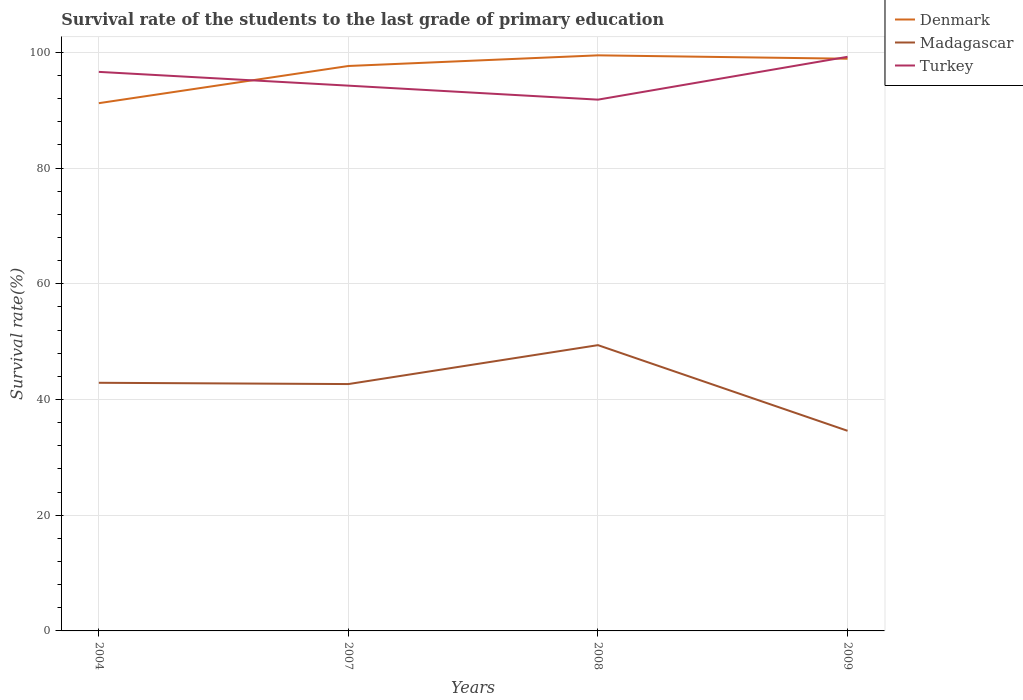How many different coloured lines are there?
Offer a terse response. 3. Does the line corresponding to Turkey intersect with the line corresponding to Madagascar?
Offer a terse response. No. Is the number of lines equal to the number of legend labels?
Provide a short and direct response. Yes. Across all years, what is the maximum survival rate of the students in Madagascar?
Make the answer very short. 34.58. What is the total survival rate of the students in Madagascar in the graph?
Offer a very short reply. 8.08. What is the difference between the highest and the second highest survival rate of the students in Denmark?
Offer a very short reply. 8.26. What is the difference between the highest and the lowest survival rate of the students in Denmark?
Make the answer very short. 3. What is the difference between two consecutive major ticks on the Y-axis?
Ensure brevity in your answer.  20. Does the graph contain any zero values?
Your answer should be compact. No. Does the graph contain grids?
Offer a very short reply. Yes. Where does the legend appear in the graph?
Offer a very short reply. Top right. How are the legend labels stacked?
Your response must be concise. Vertical. What is the title of the graph?
Provide a short and direct response. Survival rate of the students to the last grade of primary education. Does "Korea (Democratic)" appear as one of the legend labels in the graph?
Provide a short and direct response. No. What is the label or title of the X-axis?
Offer a terse response. Years. What is the label or title of the Y-axis?
Offer a terse response. Survival rate(%). What is the Survival rate(%) of Denmark in 2004?
Make the answer very short. 91.2. What is the Survival rate(%) in Madagascar in 2004?
Provide a short and direct response. 42.88. What is the Survival rate(%) in Turkey in 2004?
Ensure brevity in your answer.  96.61. What is the Survival rate(%) in Denmark in 2007?
Make the answer very short. 97.63. What is the Survival rate(%) in Madagascar in 2007?
Provide a short and direct response. 42.66. What is the Survival rate(%) of Turkey in 2007?
Give a very brief answer. 94.23. What is the Survival rate(%) of Denmark in 2008?
Provide a succinct answer. 99.47. What is the Survival rate(%) in Madagascar in 2008?
Your response must be concise. 49.39. What is the Survival rate(%) of Turkey in 2008?
Offer a very short reply. 91.81. What is the Survival rate(%) of Denmark in 2009?
Provide a succinct answer. 98.89. What is the Survival rate(%) in Madagascar in 2009?
Offer a very short reply. 34.58. What is the Survival rate(%) of Turkey in 2009?
Make the answer very short. 99.22. Across all years, what is the maximum Survival rate(%) of Denmark?
Your response must be concise. 99.47. Across all years, what is the maximum Survival rate(%) of Madagascar?
Make the answer very short. 49.39. Across all years, what is the maximum Survival rate(%) in Turkey?
Offer a very short reply. 99.22. Across all years, what is the minimum Survival rate(%) of Denmark?
Give a very brief answer. 91.2. Across all years, what is the minimum Survival rate(%) in Madagascar?
Your answer should be very brief. 34.58. Across all years, what is the minimum Survival rate(%) in Turkey?
Make the answer very short. 91.81. What is the total Survival rate(%) of Denmark in the graph?
Provide a short and direct response. 387.19. What is the total Survival rate(%) in Madagascar in the graph?
Your answer should be compact. 169.51. What is the total Survival rate(%) in Turkey in the graph?
Offer a terse response. 381.88. What is the difference between the Survival rate(%) in Denmark in 2004 and that in 2007?
Your answer should be compact. -6.43. What is the difference between the Survival rate(%) in Madagascar in 2004 and that in 2007?
Ensure brevity in your answer.  0.22. What is the difference between the Survival rate(%) of Turkey in 2004 and that in 2007?
Make the answer very short. 2.38. What is the difference between the Survival rate(%) in Denmark in 2004 and that in 2008?
Your answer should be very brief. -8.26. What is the difference between the Survival rate(%) of Madagascar in 2004 and that in 2008?
Your answer should be very brief. -6.5. What is the difference between the Survival rate(%) of Turkey in 2004 and that in 2008?
Your answer should be very brief. 4.8. What is the difference between the Survival rate(%) in Denmark in 2004 and that in 2009?
Your answer should be compact. -7.68. What is the difference between the Survival rate(%) in Madagascar in 2004 and that in 2009?
Your response must be concise. 8.3. What is the difference between the Survival rate(%) of Turkey in 2004 and that in 2009?
Give a very brief answer. -2.61. What is the difference between the Survival rate(%) in Denmark in 2007 and that in 2008?
Your response must be concise. -1.84. What is the difference between the Survival rate(%) in Madagascar in 2007 and that in 2008?
Keep it short and to the point. -6.73. What is the difference between the Survival rate(%) in Turkey in 2007 and that in 2008?
Offer a very short reply. 2.42. What is the difference between the Survival rate(%) of Denmark in 2007 and that in 2009?
Offer a very short reply. -1.26. What is the difference between the Survival rate(%) of Madagascar in 2007 and that in 2009?
Offer a terse response. 8.08. What is the difference between the Survival rate(%) in Turkey in 2007 and that in 2009?
Offer a very short reply. -4.99. What is the difference between the Survival rate(%) of Denmark in 2008 and that in 2009?
Your answer should be compact. 0.58. What is the difference between the Survival rate(%) of Madagascar in 2008 and that in 2009?
Provide a succinct answer. 14.8. What is the difference between the Survival rate(%) of Turkey in 2008 and that in 2009?
Give a very brief answer. -7.41. What is the difference between the Survival rate(%) in Denmark in 2004 and the Survival rate(%) in Madagascar in 2007?
Give a very brief answer. 48.54. What is the difference between the Survival rate(%) in Denmark in 2004 and the Survival rate(%) in Turkey in 2007?
Offer a very short reply. -3.03. What is the difference between the Survival rate(%) in Madagascar in 2004 and the Survival rate(%) in Turkey in 2007?
Ensure brevity in your answer.  -51.35. What is the difference between the Survival rate(%) of Denmark in 2004 and the Survival rate(%) of Madagascar in 2008?
Your response must be concise. 41.82. What is the difference between the Survival rate(%) in Denmark in 2004 and the Survival rate(%) in Turkey in 2008?
Provide a short and direct response. -0.61. What is the difference between the Survival rate(%) in Madagascar in 2004 and the Survival rate(%) in Turkey in 2008?
Your answer should be compact. -48.93. What is the difference between the Survival rate(%) in Denmark in 2004 and the Survival rate(%) in Madagascar in 2009?
Provide a short and direct response. 56.62. What is the difference between the Survival rate(%) in Denmark in 2004 and the Survival rate(%) in Turkey in 2009?
Your answer should be very brief. -8.01. What is the difference between the Survival rate(%) in Madagascar in 2004 and the Survival rate(%) in Turkey in 2009?
Provide a succinct answer. -56.34. What is the difference between the Survival rate(%) of Denmark in 2007 and the Survival rate(%) of Madagascar in 2008?
Your answer should be compact. 48.24. What is the difference between the Survival rate(%) of Denmark in 2007 and the Survival rate(%) of Turkey in 2008?
Your answer should be very brief. 5.82. What is the difference between the Survival rate(%) in Madagascar in 2007 and the Survival rate(%) in Turkey in 2008?
Make the answer very short. -49.15. What is the difference between the Survival rate(%) of Denmark in 2007 and the Survival rate(%) of Madagascar in 2009?
Offer a very short reply. 63.05. What is the difference between the Survival rate(%) of Denmark in 2007 and the Survival rate(%) of Turkey in 2009?
Your answer should be very brief. -1.59. What is the difference between the Survival rate(%) of Madagascar in 2007 and the Survival rate(%) of Turkey in 2009?
Your response must be concise. -56.56. What is the difference between the Survival rate(%) in Denmark in 2008 and the Survival rate(%) in Madagascar in 2009?
Provide a short and direct response. 64.88. What is the difference between the Survival rate(%) of Denmark in 2008 and the Survival rate(%) of Turkey in 2009?
Provide a succinct answer. 0.25. What is the difference between the Survival rate(%) of Madagascar in 2008 and the Survival rate(%) of Turkey in 2009?
Offer a terse response. -49.83. What is the average Survival rate(%) in Denmark per year?
Provide a short and direct response. 96.8. What is the average Survival rate(%) in Madagascar per year?
Ensure brevity in your answer.  42.38. What is the average Survival rate(%) of Turkey per year?
Keep it short and to the point. 95.47. In the year 2004, what is the difference between the Survival rate(%) of Denmark and Survival rate(%) of Madagascar?
Offer a very short reply. 48.32. In the year 2004, what is the difference between the Survival rate(%) of Denmark and Survival rate(%) of Turkey?
Your response must be concise. -5.41. In the year 2004, what is the difference between the Survival rate(%) of Madagascar and Survival rate(%) of Turkey?
Your response must be concise. -53.73. In the year 2007, what is the difference between the Survival rate(%) of Denmark and Survival rate(%) of Madagascar?
Make the answer very short. 54.97. In the year 2007, what is the difference between the Survival rate(%) in Denmark and Survival rate(%) in Turkey?
Your answer should be very brief. 3.4. In the year 2007, what is the difference between the Survival rate(%) in Madagascar and Survival rate(%) in Turkey?
Offer a very short reply. -51.57. In the year 2008, what is the difference between the Survival rate(%) in Denmark and Survival rate(%) in Madagascar?
Your response must be concise. 50.08. In the year 2008, what is the difference between the Survival rate(%) of Denmark and Survival rate(%) of Turkey?
Your response must be concise. 7.66. In the year 2008, what is the difference between the Survival rate(%) of Madagascar and Survival rate(%) of Turkey?
Provide a succinct answer. -42.43. In the year 2009, what is the difference between the Survival rate(%) of Denmark and Survival rate(%) of Madagascar?
Provide a succinct answer. 64.3. In the year 2009, what is the difference between the Survival rate(%) in Denmark and Survival rate(%) in Turkey?
Provide a succinct answer. -0.33. In the year 2009, what is the difference between the Survival rate(%) of Madagascar and Survival rate(%) of Turkey?
Provide a succinct answer. -64.63. What is the ratio of the Survival rate(%) in Denmark in 2004 to that in 2007?
Your response must be concise. 0.93. What is the ratio of the Survival rate(%) in Madagascar in 2004 to that in 2007?
Make the answer very short. 1.01. What is the ratio of the Survival rate(%) in Turkey in 2004 to that in 2007?
Offer a very short reply. 1.03. What is the ratio of the Survival rate(%) in Denmark in 2004 to that in 2008?
Your answer should be compact. 0.92. What is the ratio of the Survival rate(%) of Madagascar in 2004 to that in 2008?
Make the answer very short. 0.87. What is the ratio of the Survival rate(%) of Turkey in 2004 to that in 2008?
Provide a short and direct response. 1.05. What is the ratio of the Survival rate(%) of Denmark in 2004 to that in 2009?
Your answer should be compact. 0.92. What is the ratio of the Survival rate(%) of Madagascar in 2004 to that in 2009?
Your answer should be compact. 1.24. What is the ratio of the Survival rate(%) of Turkey in 2004 to that in 2009?
Your answer should be very brief. 0.97. What is the ratio of the Survival rate(%) of Denmark in 2007 to that in 2008?
Offer a terse response. 0.98. What is the ratio of the Survival rate(%) of Madagascar in 2007 to that in 2008?
Ensure brevity in your answer.  0.86. What is the ratio of the Survival rate(%) of Turkey in 2007 to that in 2008?
Provide a succinct answer. 1.03. What is the ratio of the Survival rate(%) in Denmark in 2007 to that in 2009?
Provide a short and direct response. 0.99. What is the ratio of the Survival rate(%) in Madagascar in 2007 to that in 2009?
Offer a terse response. 1.23. What is the ratio of the Survival rate(%) of Turkey in 2007 to that in 2009?
Your answer should be compact. 0.95. What is the ratio of the Survival rate(%) in Denmark in 2008 to that in 2009?
Your answer should be very brief. 1.01. What is the ratio of the Survival rate(%) of Madagascar in 2008 to that in 2009?
Provide a succinct answer. 1.43. What is the ratio of the Survival rate(%) in Turkey in 2008 to that in 2009?
Make the answer very short. 0.93. What is the difference between the highest and the second highest Survival rate(%) of Denmark?
Offer a terse response. 0.58. What is the difference between the highest and the second highest Survival rate(%) in Madagascar?
Offer a terse response. 6.5. What is the difference between the highest and the second highest Survival rate(%) of Turkey?
Your response must be concise. 2.61. What is the difference between the highest and the lowest Survival rate(%) in Denmark?
Offer a terse response. 8.26. What is the difference between the highest and the lowest Survival rate(%) in Madagascar?
Offer a very short reply. 14.8. What is the difference between the highest and the lowest Survival rate(%) in Turkey?
Your answer should be very brief. 7.41. 